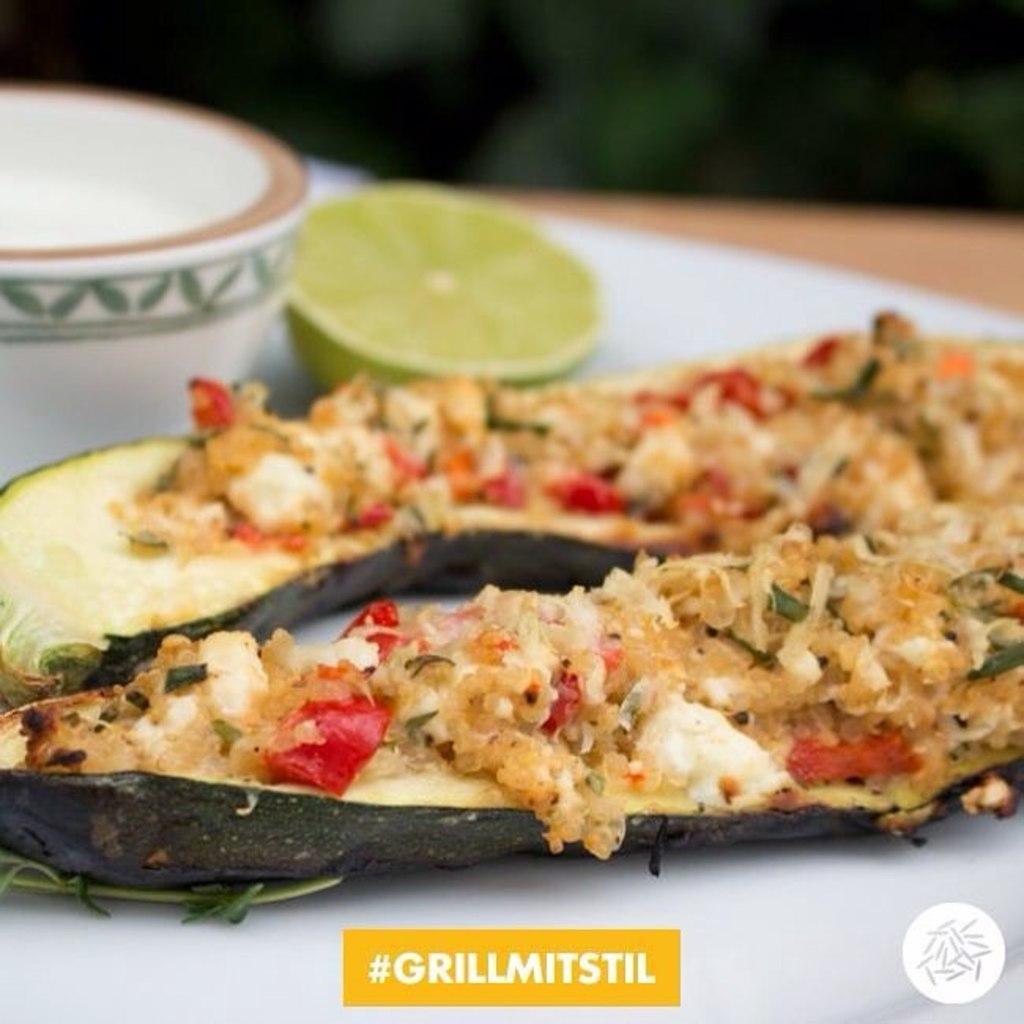Can you describe this image briefly? Here in this picture we can see some food items present on a plate and beside that we can see a piece of lemon and a bowl also present. 